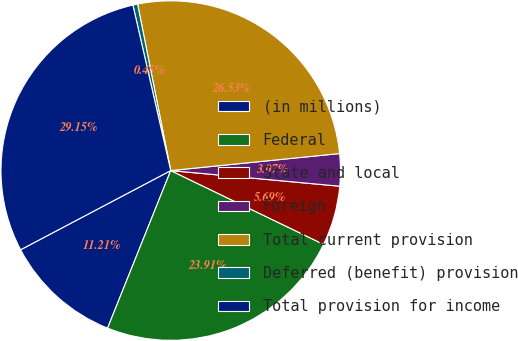<chart> <loc_0><loc_0><loc_500><loc_500><pie_chart><fcel>(in millions)<fcel>Federal<fcel>State and local<fcel>Foreign<fcel>Total current provision<fcel>Deferred (benefit) provision<fcel>Total provision for income<nl><fcel>11.21%<fcel>23.91%<fcel>5.69%<fcel>3.07%<fcel>26.53%<fcel>0.45%<fcel>29.15%<nl></chart> 